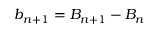<formula> <loc_0><loc_0><loc_500><loc_500>b _ { n + 1 } = B _ { n + 1 } - B _ { n }</formula> 